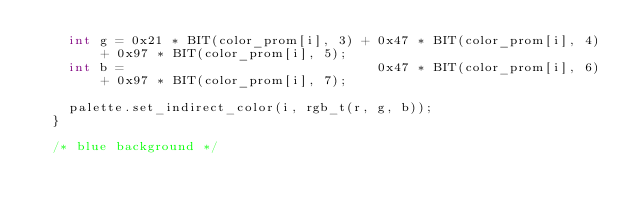Convert code to text. <code><loc_0><loc_0><loc_500><loc_500><_C++_>		int g = 0x21 * BIT(color_prom[i], 3) + 0x47 * BIT(color_prom[i], 4) + 0x97 * BIT(color_prom[i], 5);
		int b =                                0x47 * BIT(color_prom[i], 6) + 0x97 * BIT(color_prom[i], 7);

		palette.set_indirect_color(i, rgb_t(r, g, b));
	}

	/* blue background */</code> 